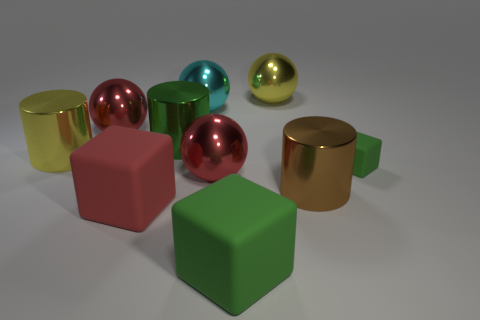Subtract all brown balls. Subtract all gray cylinders. How many balls are left? 4 Subtract all cylinders. How many objects are left? 7 Subtract 0 cyan cylinders. How many objects are left? 10 Subtract all metallic spheres. Subtract all large green rubber things. How many objects are left? 5 Add 2 big yellow metal spheres. How many big yellow metal spheres are left? 3 Add 7 large cylinders. How many large cylinders exist? 10 